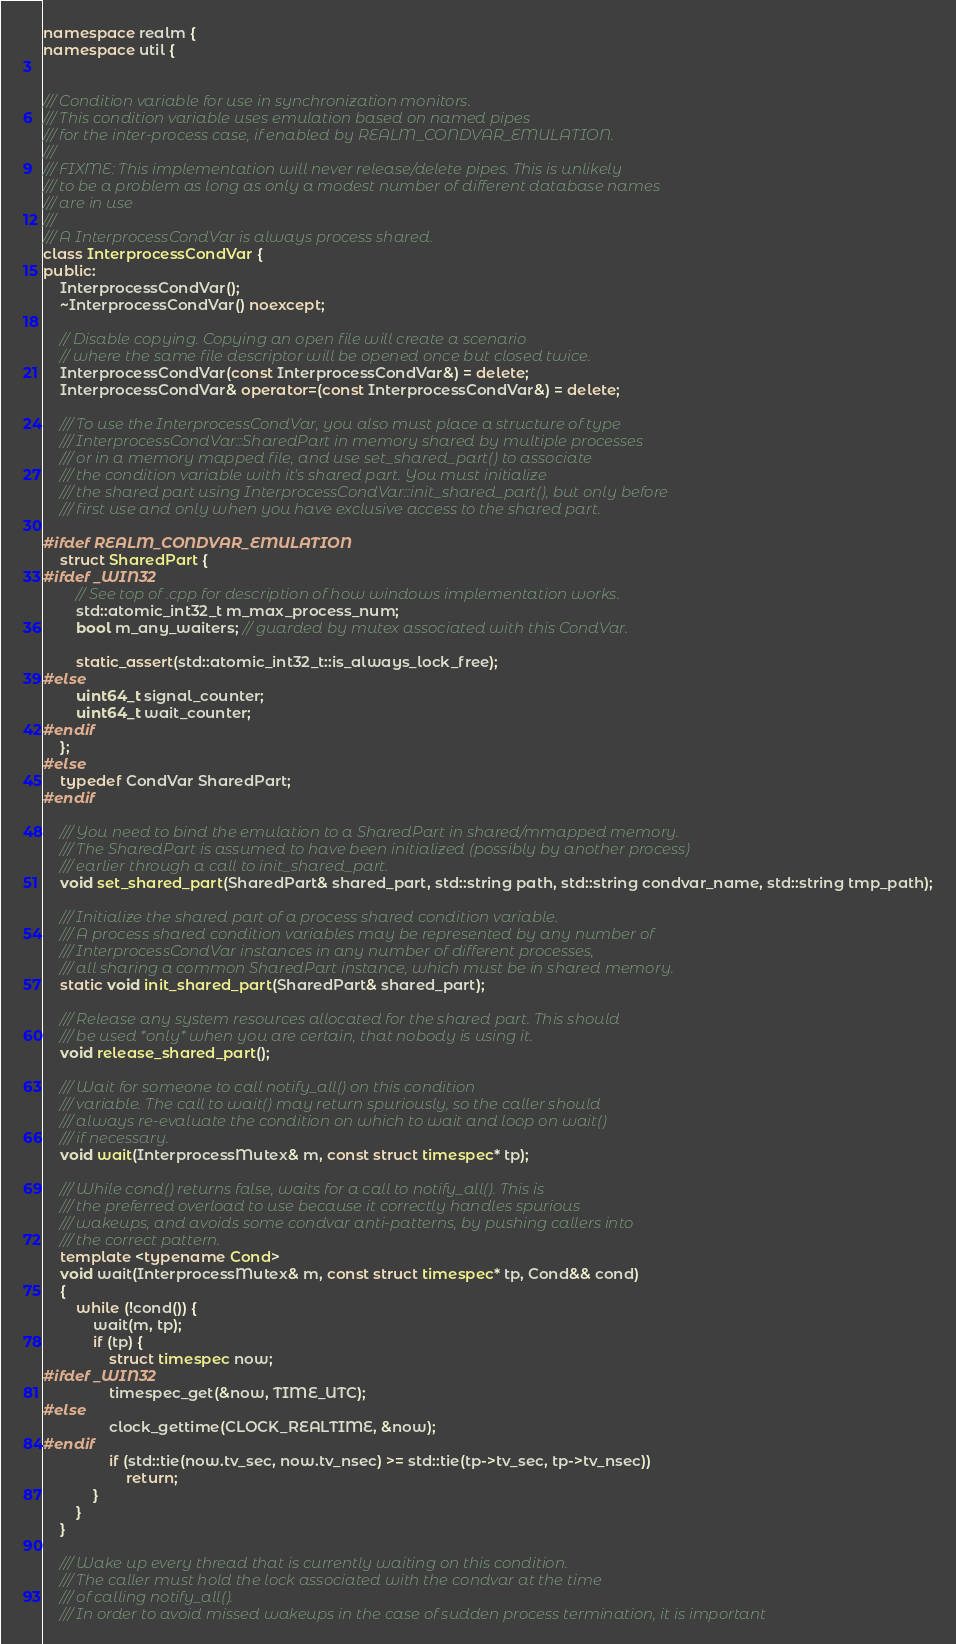<code> <loc_0><loc_0><loc_500><loc_500><_C++_>
namespace realm {
namespace util {


/// Condition variable for use in synchronization monitors.
/// This condition variable uses emulation based on named pipes
/// for the inter-process case, if enabled by REALM_CONDVAR_EMULATION.
///
/// FIXME: This implementation will never release/delete pipes. This is unlikely
/// to be a problem as long as only a modest number of different database names
/// are in use
///
/// A InterprocessCondVar is always process shared.
class InterprocessCondVar {
public:
    InterprocessCondVar();
    ~InterprocessCondVar() noexcept;

    // Disable copying. Copying an open file will create a scenario
    // where the same file descriptor will be opened once but closed twice.
    InterprocessCondVar(const InterprocessCondVar&) = delete;
    InterprocessCondVar& operator=(const InterprocessCondVar&) = delete;

    /// To use the InterprocessCondVar, you also must place a structure of type
    /// InterprocessCondVar::SharedPart in memory shared by multiple processes
    /// or in a memory mapped file, and use set_shared_part() to associate
    /// the condition variable with it's shared part. You must initialize
    /// the shared part using InterprocessCondVar::init_shared_part(), but only before
    /// first use and only when you have exclusive access to the shared part.

#ifdef REALM_CONDVAR_EMULATION
    struct SharedPart {
#ifdef _WIN32
        // See top of .cpp for description of how windows implementation works.
        std::atomic_int32_t m_max_process_num;
        bool m_any_waiters; // guarded by mutex associated with this CondVar.

        static_assert(std::atomic_int32_t::is_always_lock_free);
#else
        uint64_t signal_counter;
        uint64_t wait_counter;
#endif
    };
#else
    typedef CondVar SharedPart;
#endif

    /// You need to bind the emulation to a SharedPart in shared/mmapped memory.
    /// The SharedPart is assumed to have been initialized (possibly by another process)
    /// earlier through a call to init_shared_part.
    void set_shared_part(SharedPart& shared_part, std::string path, std::string condvar_name, std::string tmp_path);

    /// Initialize the shared part of a process shared condition variable.
    /// A process shared condition variables may be represented by any number of
    /// InterprocessCondVar instances in any number of different processes,
    /// all sharing a common SharedPart instance, which must be in shared memory.
    static void init_shared_part(SharedPart& shared_part);

    /// Release any system resources allocated for the shared part. This should
    /// be used *only* when you are certain, that nobody is using it.
    void release_shared_part();

    /// Wait for someone to call notify_all() on this condition
    /// variable. The call to wait() may return spuriously, so the caller should
    /// always re-evaluate the condition on which to wait and loop on wait()
    /// if necessary.
    void wait(InterprocessMutex& m, const struct timespec* tp);

    /// While cond() returns false, waits for a call to notify_all(). This is
    /// the preferred overload to use because it correctly handles spurious
    /// wakeups, and avoids some condvar anti-patterns, by pushing callers into
    /// the correct pattern.
    template <typename Cond>
    void wait(InterprocessMutex& m, const struct timespec* tp, Cond&& cond)
    {
        while (!cond()) {
            wait(m, tp);
            if (tp) {
                struct timespec now;
#ifdef _WIN32
                timespec_get(&now, TIME_UTC);
#else
                clock_gettime(CLOCK_REALTIME, &now);
#endif
                if (std::tie(now.tv_sec, now.tv_nsec) >= std::tie(tp->tv_sec, tp->tv_nsec))
                    return;
            }
        }
    }

    /// Wake up every thread that is currently waiting on this condition.
    /// The caller must hold the lock associated with the condvar at the time
    /// of calling notify_all().
    /// In order to avoid missed wakeups in the case of sudden process termination, it is important</code> 